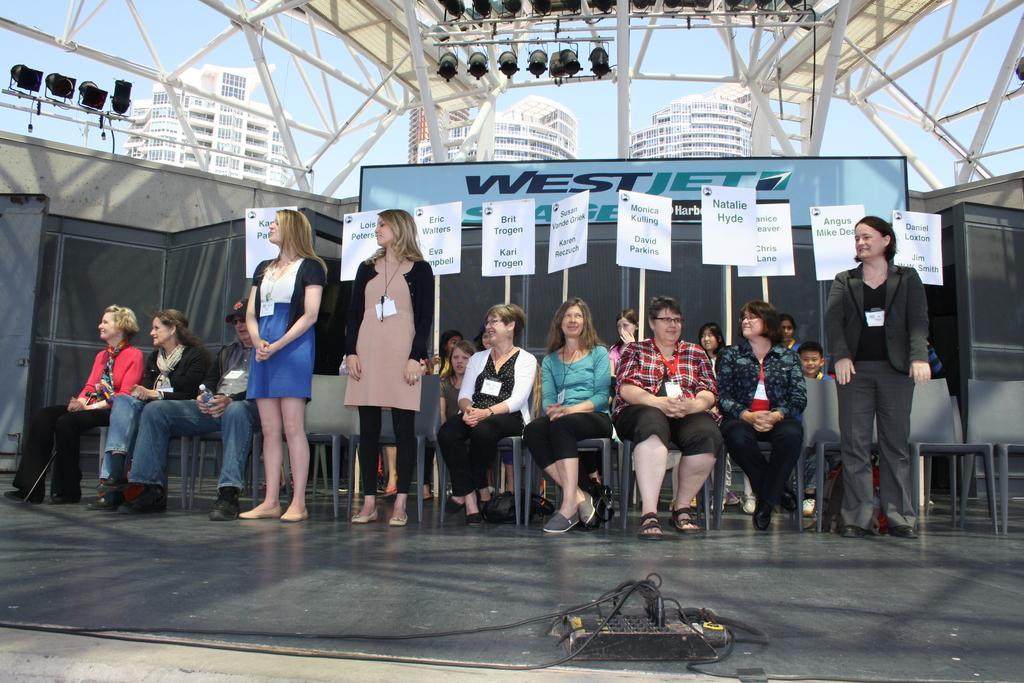How would you summarize this image in a sentence or two? In this image we can see group of people. three people standing on the floor. A group of people sitting in chairs. One person wearing a jacket and a cap is holding a bottle in his hand. In the background, we can see group of sign boards with text, a group of lights, poles and a group of building and the sky. 